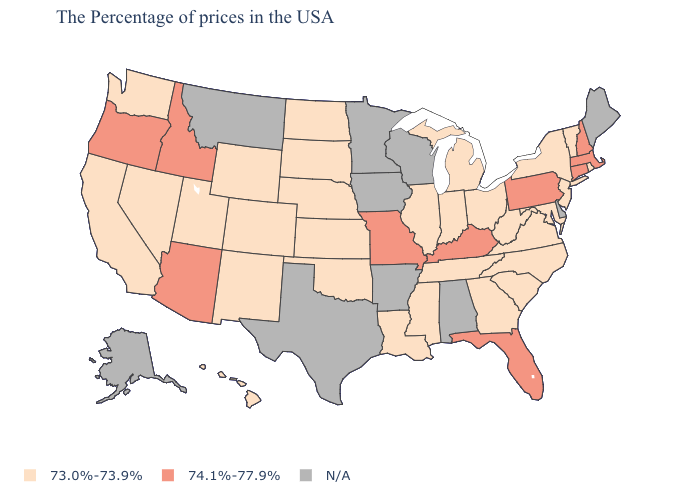Does the first symbol in the legend represent the smallest category?
Concise answer only. Yes. Does Vermont have the lowest value in the USA?
Short answer required. Yes. What is the value of North Carolina?
Be succinct. 73.0%-73.9%. What is the value of California?
Quick response, please. 73.0%-73.9%. Does Connecticut have the highest value in the Northeast?
Quick response, please. Yes. Name the states that have a value in the range 73.0%-73.9%?
Keep it brief. Rhode Island, Vermont, New York, New Jersey, Maryland, Virginia, North Carolina, South Carolina, West Virginia, Ohio, Georgia, Michigan, Indiana, Tennessee, Illinois, Mississippi, Louisiana, Kansas, Nebraska, Oklahoma, South Dakota, North Dakota, Wyoming, Colorado, New Mexico, Utah, Nevada, California, Washington, Hawaii. What is the highest value in states that border Kansas?
Quick response, please. 74.1%-77.9%. Does Hawaii have the highest value in the West?
Concise answer only. No. Name the states that have a value in the range 74.1%-77.9%?
Concise answer only. Massachusetts, New Hampshire, Connecticut, Pennsylvania, Florida, Kentucky, Missouri, Arizona, Idaho, Oregon. Name the states that have a value in the range 74.1%-77.9%?
Answer briefly. Massachusetts, New Hampshire, Connecticut, Pennsylvania, Florida, Kentucky, Missouri, Arizona, Idaho, Oregon. Is the legend a continuous bar?
Short answer required. No. Name the states that have a value in the range N/A?
Keep it brief. Maine, Delaware, Alabama, Wisconsin, Arkansas, Minnesota, Iowa, Texas, Montana, Alaska. Name the states that have a value in the range 73.0%-73.9%?
Concise answer only. Rhode Island, Vermont, New York, New Jersey, Maryland, Virginia, North Carolina, South Carolina, West Virginia, Ohio, Georgia, Michigan, Indiana, Tennessee, Illinois, Mississippi, Louisiana, Kansas, Nebraska, Oklahoma, South Dakota, North Dakota, Wyoming, Colorado, New Mexico, Utah, Nevada, California, Washington, Hawaii. 